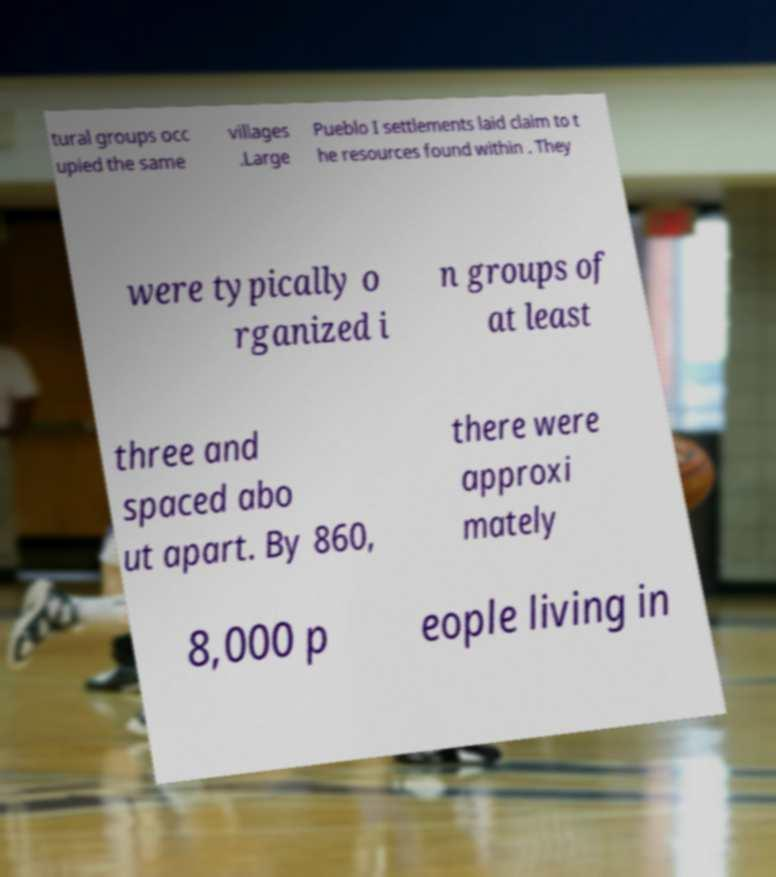Please identify and transcribe the text found in this image. tural groups occ upied the same villages .Large Pueblo I settlements laid claim to t he resources found within . They were typically o rganized i n groups of at least three and spaced abo ut apart. By 860, there were approxi mately 8,000 p eople living in 